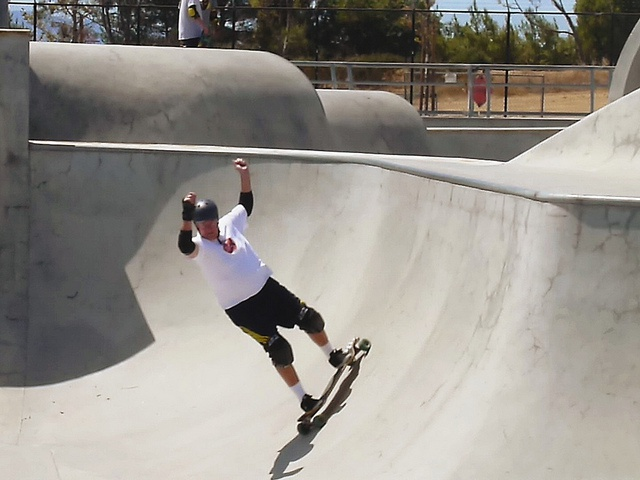Describe the objects in this image and their specific colors. I can see people in black, darkgray, gray, and lightgray tones, people in black, gray, darkgray, and lightgray tones, and skateboard in black, gray, and darkgray tones in this image. 